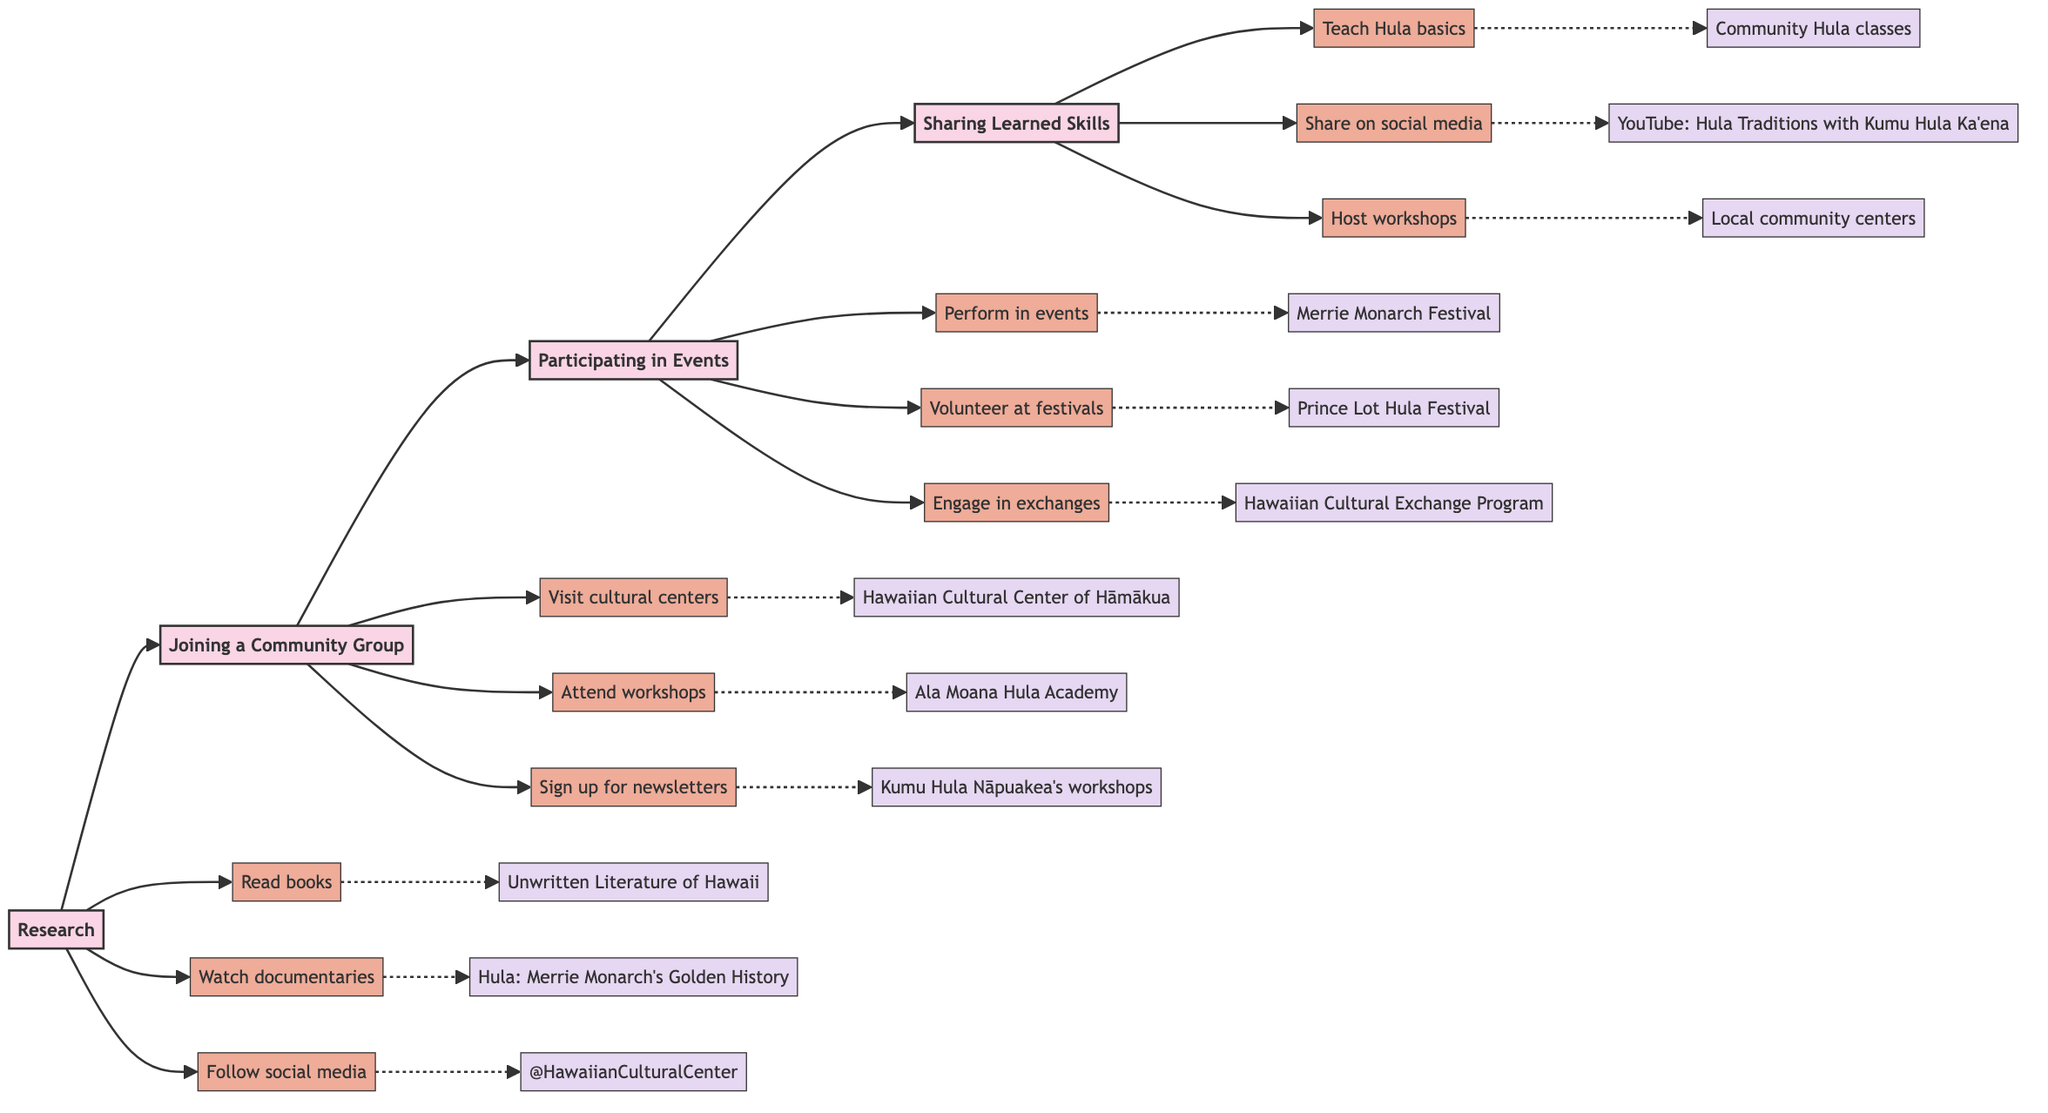What is the first step in the path to cultural immersion? The diagram indicates that the first step is "Research". It is the initial node that flows into "Joining a Community Group".
Answer: Research How many major stages are there in the cultural immersion process? By counting the main nodes in the diagram, there are four stages: Research, Joining a Community Group, Participating in Events, and Sharing Learned Skills.
Answer: 4 What action follows 'Joining a Community Group'? The diagram shows that after 'Joining a Community Group', the next action is 'Participating in Events', which is the following node in the flowchart.
Answer: Participating in Events Which stage includes volunteering at festivals? The action "Volunteer at cultural festivals and fairs" is found in the 'Participating in Events' stage. This stage illustrates various ways to engage actively in cultural experiences.
Answer: Participating in Events What is one key resource listed under the 'Research' stage? Looking at the 'Research' stage, a key resource listed is "Book: 'Unwritten Literature of Hawaii: The Sacred Songs of the Hula'". It signifies an important reference for researching Hawaiian performing arts.
Answer: Unwritten Literature of Hawaii How do the stages relate to each other in the flowchart? The flow of the diagram indicates a linear progression where each stage leads to the next: Research leads to Joining a Community Group, which leads to Participating in Events, and finally to Sharing Learned Skills. This shows a step-by-step approach to cultural immersion.
Answer: Linear progression Which action can you take in the 'Sharing Learned Skills' stage? In the 'Sharing Learned Skills' stage, one of the actions you can take is "Teach Hula basics to younger generations", which emphasizes the importance of passing down knowledge.
Answer: Teach Hula basics What is the last stage in the diagram focused on? The last stage, 'Sharing Learned Skills', focuses on the results of the entire process, emphasizing teaching, performing, and sharing the cultural practices you've learned throughout your journey.
Answer: Sharing Learned Skills What are the two key resources associated with 'Participating in Events'? The two key resources associated with 'Participating in Events' are "Merrie Monarch Festival" and "Prince Lot Hula Festival". These are notable cultural events where participation is encouraged.
Answer: Merrie Monarch Festival, Prince Lot Hula Festival 